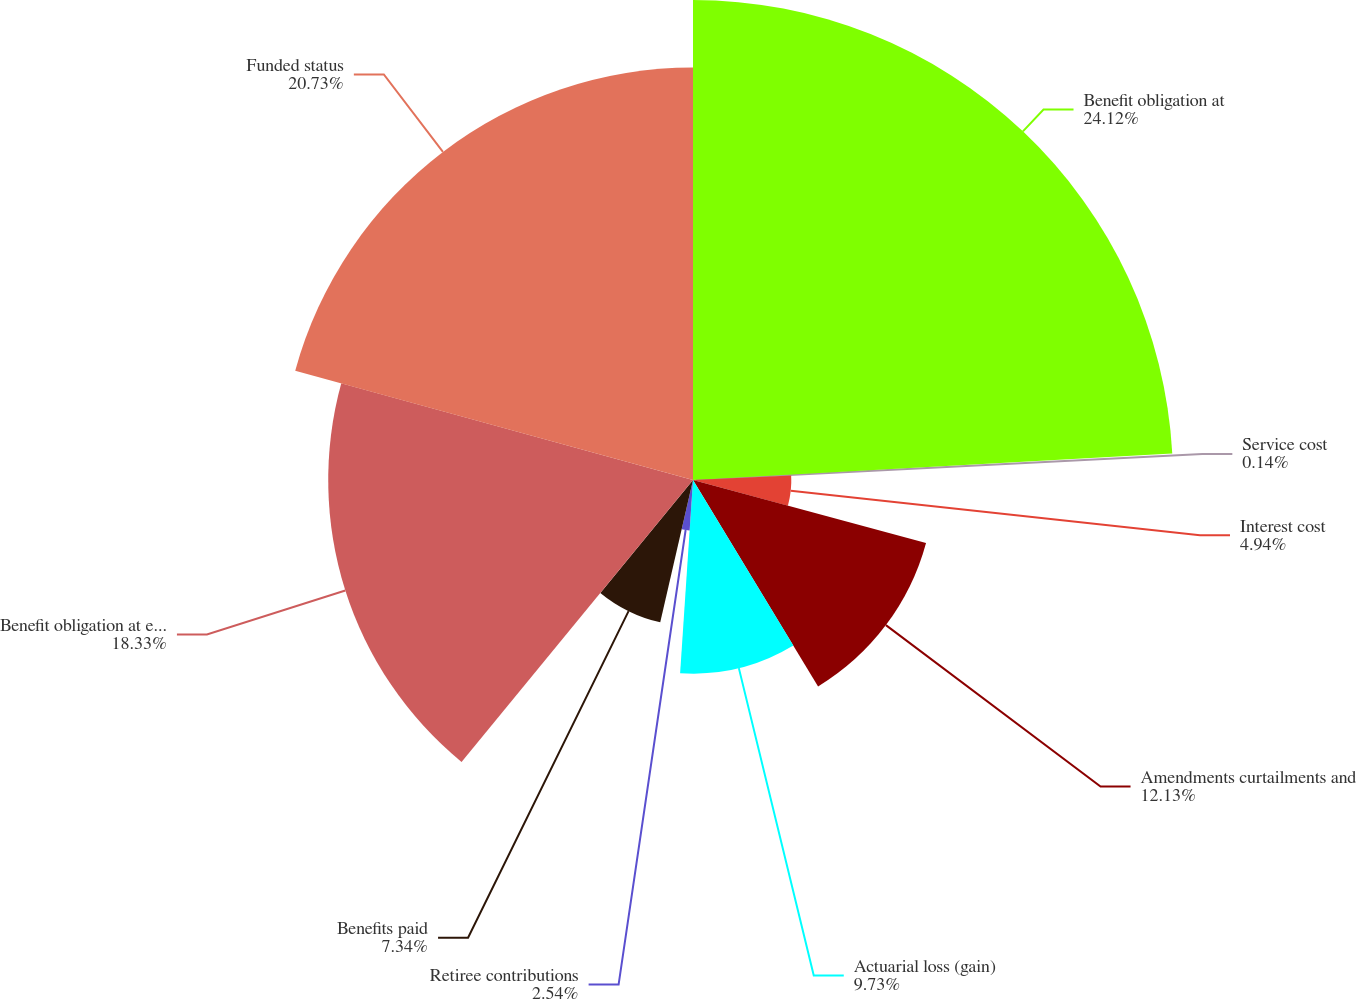<chart> <loc_0><loc_0><loc_500><loc_500><pie_chart><fcel>Benefit obligation at<fcel>Service cost<fcel>Interest cost<fcel>Amendments curtailments and<fcel>Actuarial loss (gain)<fcel>Retiree contributions<fcel>Benefits paid<fcel>Benefit obligation at end of<fcel>Funded status<nl><fcel>24.12%<fcel>0.14%<fcel>4.94%<fcel>12.13%<fcel>9.73%<fcel>2.54%<fcel>7.34%<fcel>18.33%<fcel>20.73%<nl></chart> 